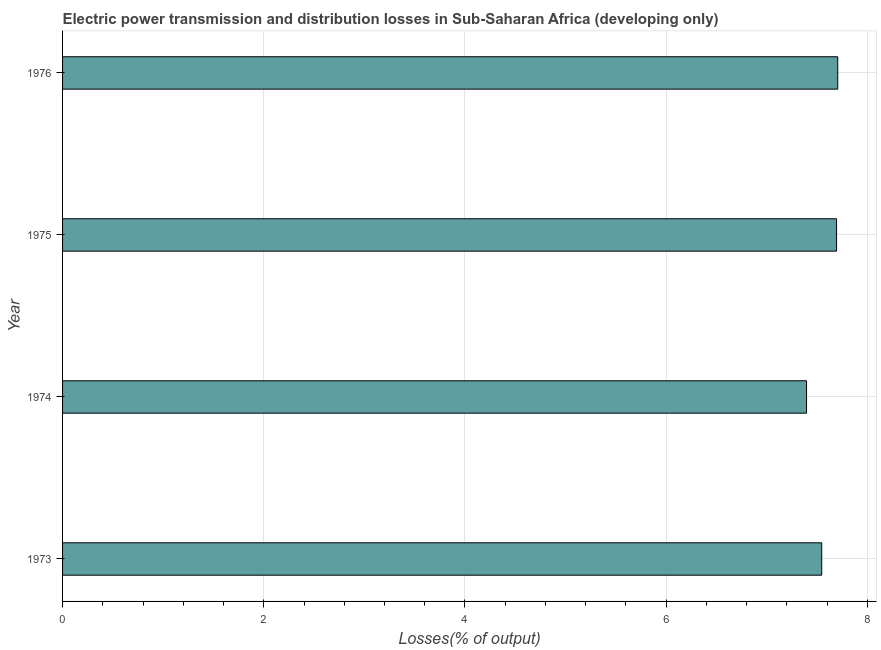Does the graph contain grids?
Provide a succinct answer. Yes. What is the title of the graph?
Offer a very short reply. Electric power transmission and distribution losses in Sub-Saharan Africa (developing only). What is the label or title of the X-axis?
Keep it short and to the point. Losses(% of output). What is the electric power transmission and distribution losses in 1974?
Provide a succinct answer. 7.4. Across all years, what is the maximum electric power transmission and distribution losses?
Ensure brevity in your answer.  7.71. Across all years, what is the minimum electric power transmission and distribution losses?
Make the answer very short. 7.4. In which year was the electric power transmission and distribution losses maximum?
Give a very brief answer. 1976. In which year was the electric power transmission and distribution losses minimum?
Make the answer very short. 1974. What is the sum of the electric power transmission and distribution losses?
Give a very brief answer. 30.34. What is the difference between the electric power transmission and distribution losses in 1974 and 1975?
Offer a terse response. -0.3. What is the average electric power transmission and distribution losses per year?
Make the answer very short. 7.58. What is the median electric power transmission and distribution losses?
Make the answer very short. 7.62. What is the ratio of the electric power transmission and distribution losses in 1974 to that in 1975?
Provide a short and direct response. 0.96. Is the electric power transmission and distribution losses in 1974 less than that in 1975?
Offer a very short reply. Yes. Is the difference between the electric power transmission and distribution losses in 1974 and 1975 greater than the difference between any two years?
Your response must be concise. No. What is the difference between the highest and the second highest electric power transmission and distribution losses?
Offer a terse response. 0.01. What is the difference between the highest and the lowest electric power transmission and distribution losses?
Ensure brevity in your answer.  0.31. In how many years, is the electric power transmission and distribution losses greater than the average electric power transmission and distribution losses taken over all years?
Offer a terse response. 2. How many bars are there?
Your answer should be very brief. 4. How many years are there in the graph?
Make the answer very short. 4. What is the Losses(% of output) in 1973?
Give a very brief answer. 7.55. What is the Losses(% of output) of 1974?
Ensure brevity in your answer.  7.4. What is the Losses(% of output) in 1975?
Your answer should be very brief. 7.69. What is the Losses(% of output) of 1976?
Your answer should be compact. 7.71. What is the difference between the Losses(% of output) in 1973 and 1974?
Your answer should be very brief. 0.15. What is the difference between the Losses(% of output) in 1973 and 1975?
Make the answer very short. -0.15. What is the difference between the Losses(% of output) in 1973 and 1976?
Your answer should be very brief. -0.16. What is the difference between the Losses(% of output) in 1974 and 1975?
Keep it short and to the point. -0.3. What is the difference between the Losses(% of output) in 1974 and 1976?
Offer a terse response. -0.31. What is the difference between the Losses(% of output) in 1975 and 1976?
Offer a terse response. -0.01. What is the ratio of the Losses(% of output) in 1973 to that in 1974?
Your answer should be compact. 1.02. What is the ratio of the Losses(% of output) in 1973 to that in 1975?
Offer a very short reply. 0.98. What is the ratio of the Losses(% of output) in 1974 to that in 1975?
Provide a succinct answer. 0.96. What is the ratio of the Losses(% of output) in 1974 to that in 1976?
Offer a terse response. 0.96. What is the ratio of the Losses(% of output) in 1975 to that in 1976?
Ensure brevity in your answer.  1. 